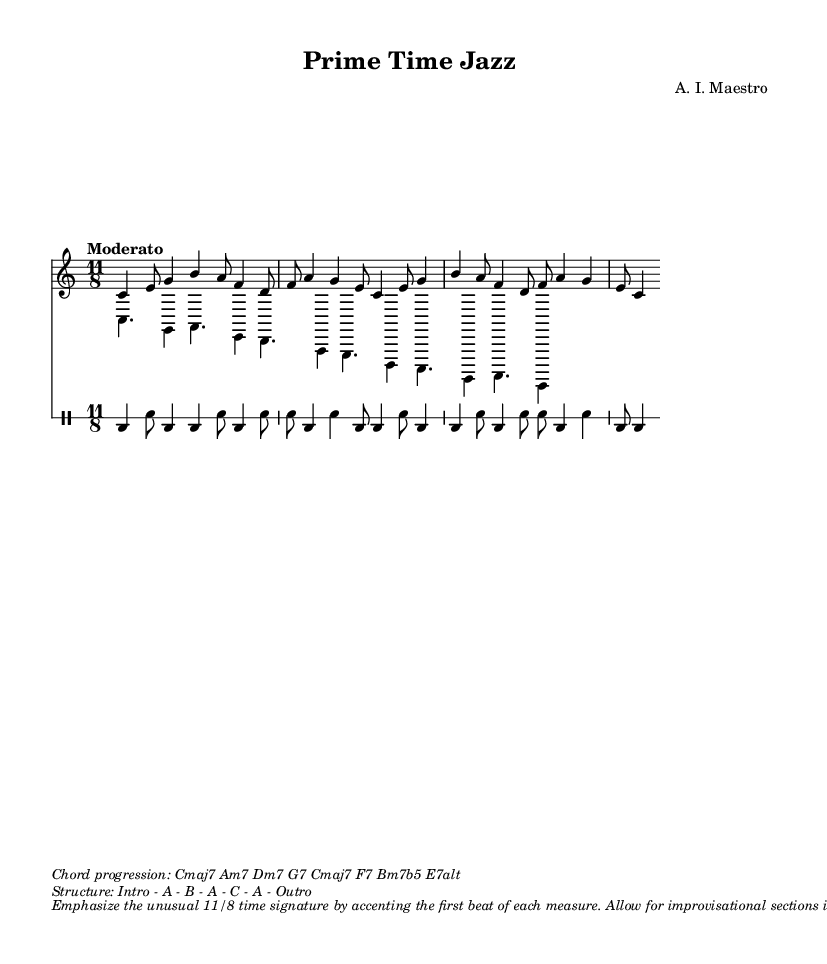What is the time signature of this music? The time signature is indicated at the beginning of the score as 11/8, which means there are 11 eighth notes per measure.
Answer: 11/8 What is the key signature of this music? The key signature is C major, meaning there are no sharps or flats, which is shown at the start of the score.
Answer: C major What is the tempo marking for this composition? The tempo marking specified in the score is "Moderato," which suggests a moderate speed for the performance.
Answer: Moderato What is the structure of this composition? The structure is provided in a separate markup section that breaks down the form as: Intro - A - B - A - C - A - Outro. This indicates the sections and their order.
Answer: Intro - A - B - A - C - A - Outro What chord progression is used in this piece? The chord progression is listed in the score and includes the following chords: Cmaj7 Am7 Dm7 G7 Cmaj7 F7 Bm7b5 E7alt, showing the harmonic structure of the piece.
Answer: Cmaj7 Am7 Dm7 G7 Cmaj7 F7 Bm7b5 E7alt How should the unusual 11/8 time signature be emphasized in performance? The score suggests that musicians should accent the first beat of each measure to highlight the 11/8 time signature, which is an unusual choice for jazz compositions.
Answer: Accent the first beat of each measure What sections allow for improvisation in this composition? The score indicates in the markup that improvisational sections are permitted specifically in the B and C parts of the structure, allowing musicians to explore creativity in those areas.
Answer: B and C 